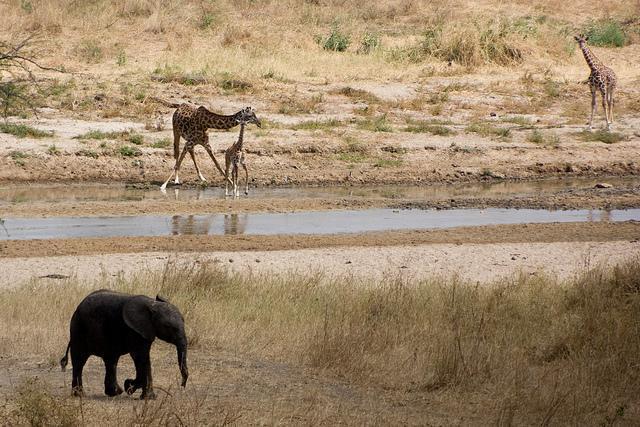Why does that animal have its legs spread?
Answer the question by selecting the correct answer among the 4 following choices.
Options: To drink, to sleep, to hide, to swim. To drink. 